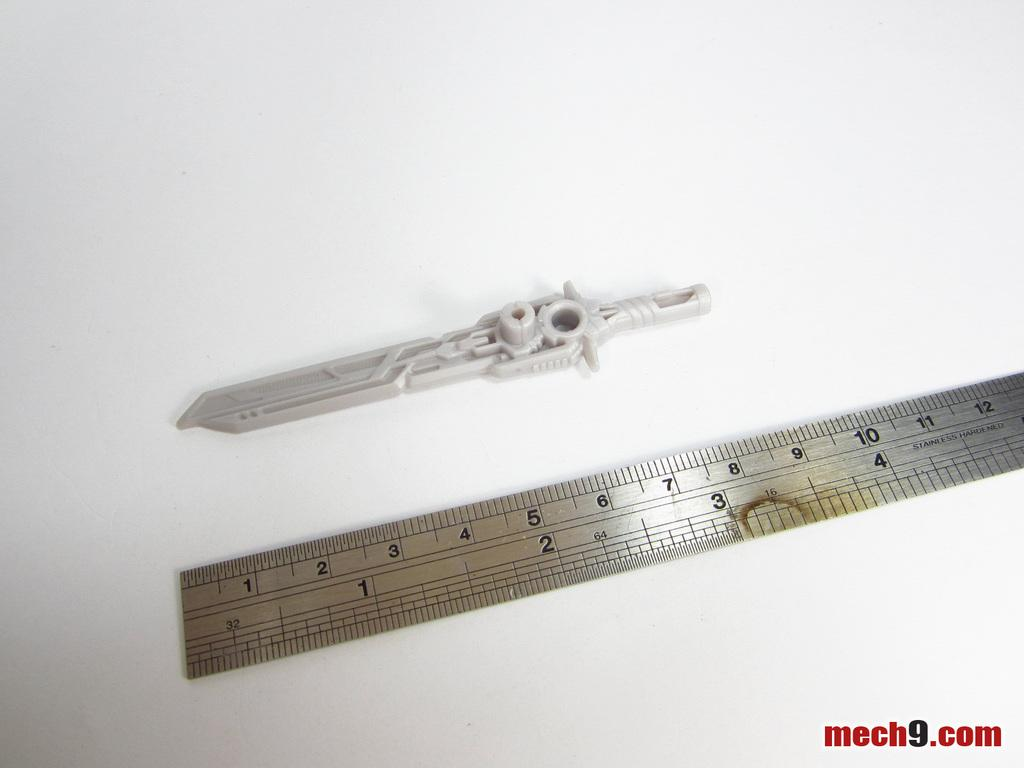<image>
Describe the image concisely. A ruler next to another measuring tool with the words mech9.com at the bottom. 